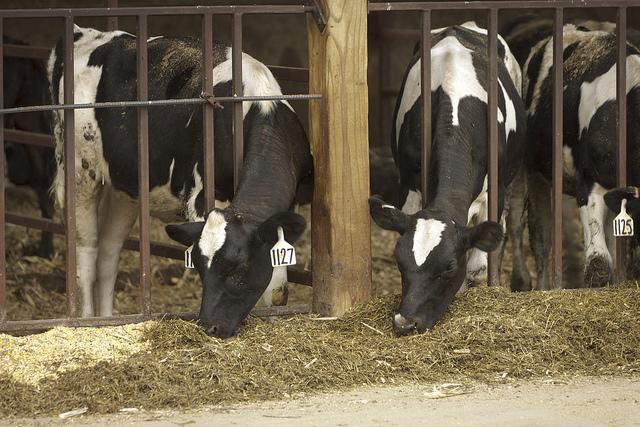What could be the purpose of the metal bars around the cows? The metal bars around the cows are likely to ensure that they stay in their designated feeding or resting area, preventing them from wandering off and ensuring their safety in a communal space. Are there any other systems farmers might use to manage their dairy cows efficiently? Yes, farmers often employ various systems to manage dairy cows efficiently, such as automated milking machines, feeding systems that deliver the right amount of nutrition, and health monitoring devices to check for signs of illness or stress. 